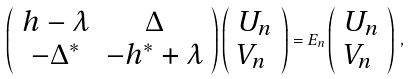<formula> <loc_0><loc_0><loc_500><loc_500>\left ( \begin{array} { c c } h - \lambda & \Delta \\ - \Delta ^ { * } & - h ^ { * } + \lambda \end{array} \right ) \left ( \begin{array} { l } U _ { n } \\ V _ { n } \end{array} \right ) = E _ { n } \left ( \begin{array} { l } U _ { n } \\ V _ { n } \end{array} \right ) \, ,</formula> 